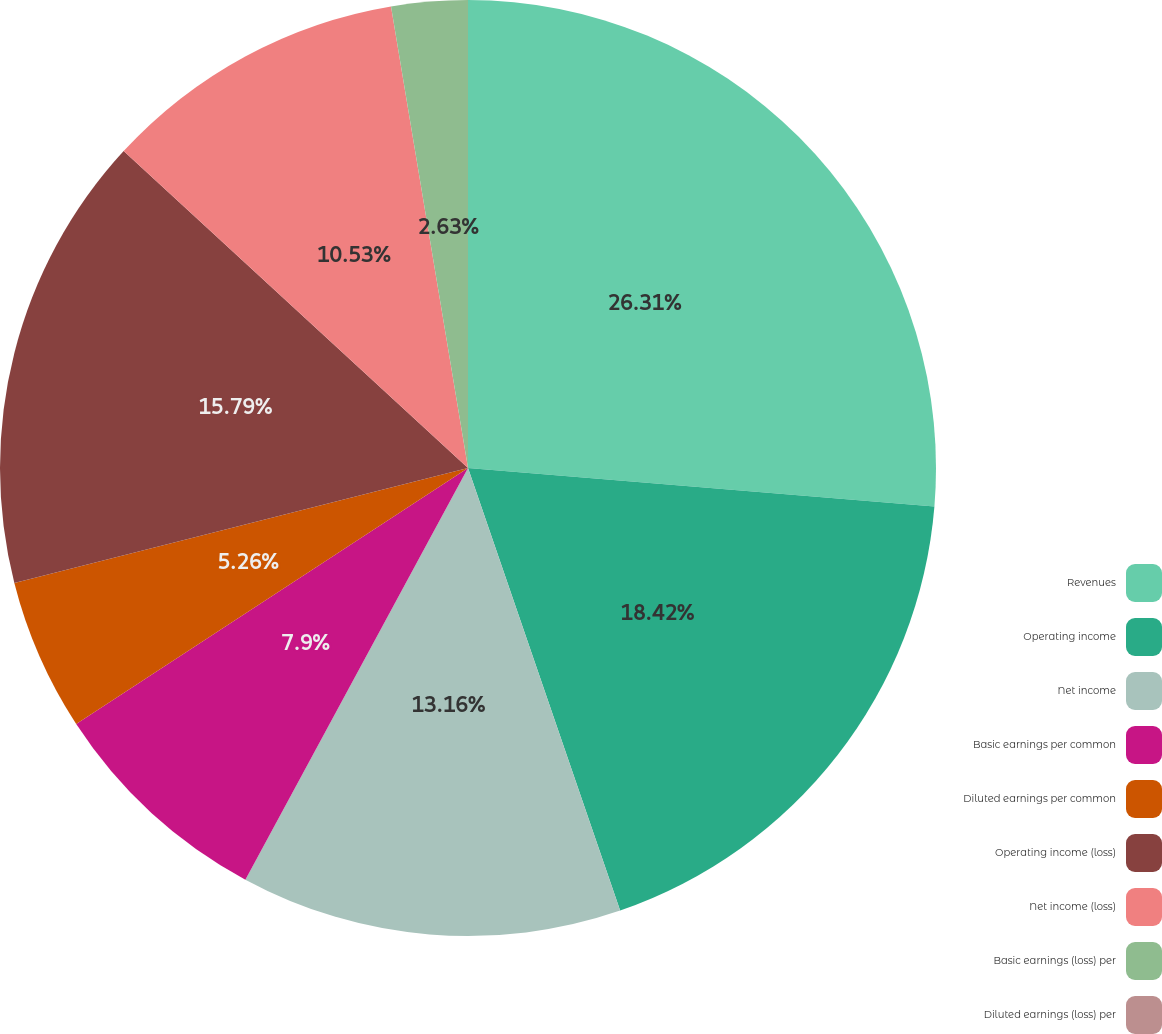Convert chart to OTSL. <chart><loc_0><loc_0><loc_500><loc_500><pie_chart><fcel>Revenues<fcel>Operating income<fcel>Net income<fcel>Basic earnings per common<fcel>Diluted earnings per common<fcel>Operating income (loss)<fcel>Net income (loss)<fcel>Basic earnings (loss) per<fcel>Diluted earnings (loss) per<nl><fcel>26.31%<fcel>18.42%<fcel>13.16%<fcel>7.9%<fcel>5.26%<fcel>15.79%<fcel>10.53%<fcel>2.63%<fcel>0.0%<nl></chart> 